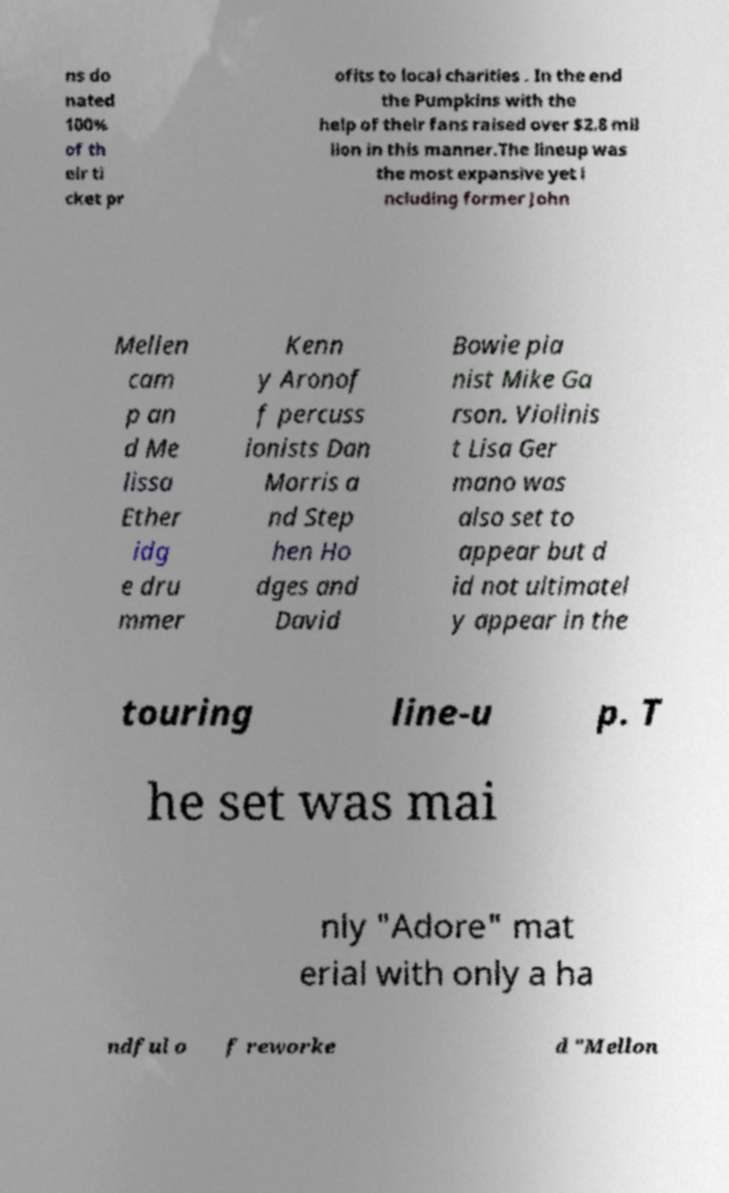Can you accurately transcribe the text from the provided image for me? ns do nated 100% of th eir ti cket pr ofits to local charities . In the end the Pumpkins with the help of their fans raised over $2.8 mil lion in this manner.The lineup was the most expansive yet i ncluding former John Mellen cam p an d Me lissa Ether idg e dru mmer Kenn y Aronof f percuss ionists Dan Morris a nd Step hen Ho dges and David Bowie pia nist Mike Ga rson. Violinis t Lisa Ger mano was also set to appear but d id not ultimatel y appear in the touring line-u p. T he set was mai nly "Adore" mat erial with only a ha ndful o f reworke d "Mellon 